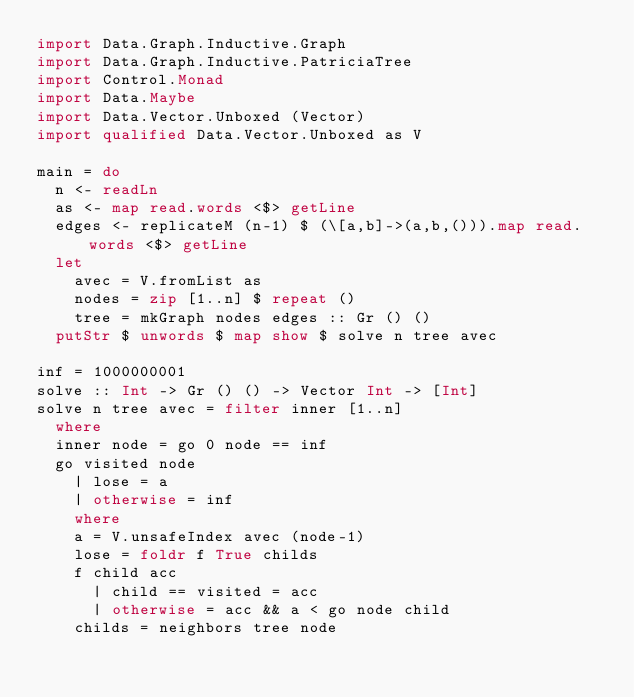Convert code to text. <code><loc_0><loc_0><loc_500><loc_500><_Haskell_>import Data.Graph.Inductive.Graph
import Data.Graph.Inductive.PatriciaTree
import Control.Monad
import Data.Maybe
import Data.Vector.Unboxed (Vector)
import qualified Data.Vector.Unboxed as V

main = do
  n <- readLn
  as <- map read.words <$> getLine
  edges <- replicateM (n-1) $ (\[a,b]->(a,b,())).map read.words <$> getLine
  let
    avec = V.fromList as
    nodes = zip [1..n] $ repeat ()
    tree = mkGraph nodes edges :: Gr () ()
  putStr $ unwords $ map show $ solve n tree avec

inf = 1000000001
solve :: Int -> Gr () () -> Vector Int -> [Int]
solve n tree avec = filter inner [1..n]
  where
  inner node = go 0 node == inf
  go visited node
    | lose = a
    | otherwise = inf
    where
    a = V.unsafeIndex avec (node-1)
    lose = foldr f True childs
    f child acc
      | child == visited = acc
      | otherwise = acc && a < go node child
    childs = neighbors tree node</code> 